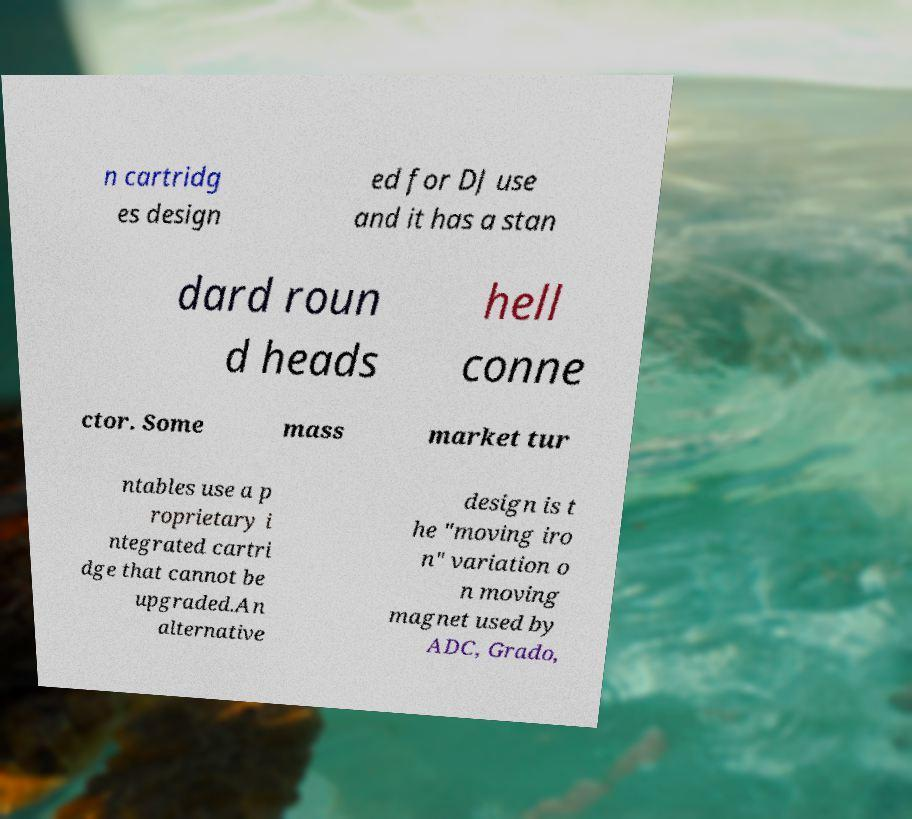There's text embedded in this image that I need extracted. Can you transcribe it verbatim? n cartridg es design ed for DJ use and it has a stan dard roun d heads hell conne ctor. Some mass market tur ntables use a p roprietary i ntegrated cartri dge that cannot be upgraded.An alternative design is t he "moving iro n" variation o n moving magnet used by ADC, Grado, 